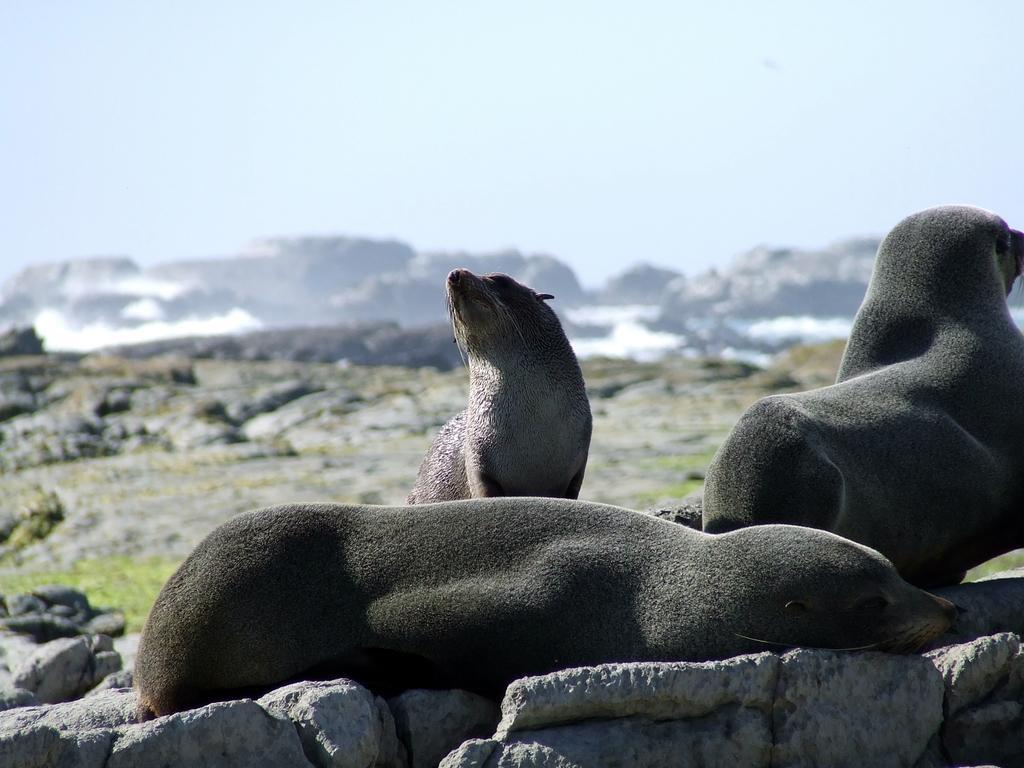How would you summarize this image in a sentence or two? In this image there are animals on the rocks, there is an animal truncated towards the right of the image, there are rocks truncated towards the bottom of the image, there is a mountain truncated towards the left of the image, there is a mountain truncated towards the right of the image, there is the sky truncated towards the top of the image, there is the grass. 